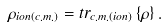<formula> <loc_0><loc_0><loc_500><loc_500>\rho _ { i o n ( c . m . ) } = t r _ { c . m . ( i o n ) } \left \{ \rho \right \} .</formula> 